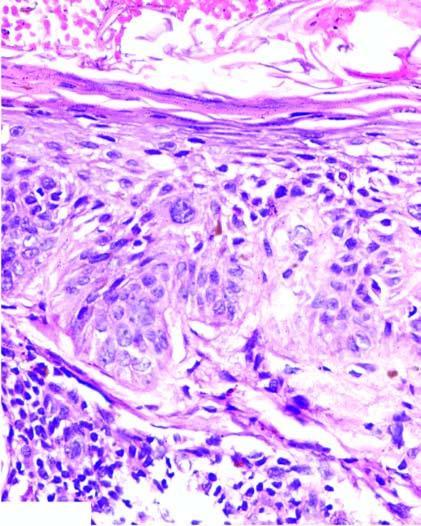what is the epidermis thick with?
Answer the question using a single word or phrase. Loss of rete ridges 